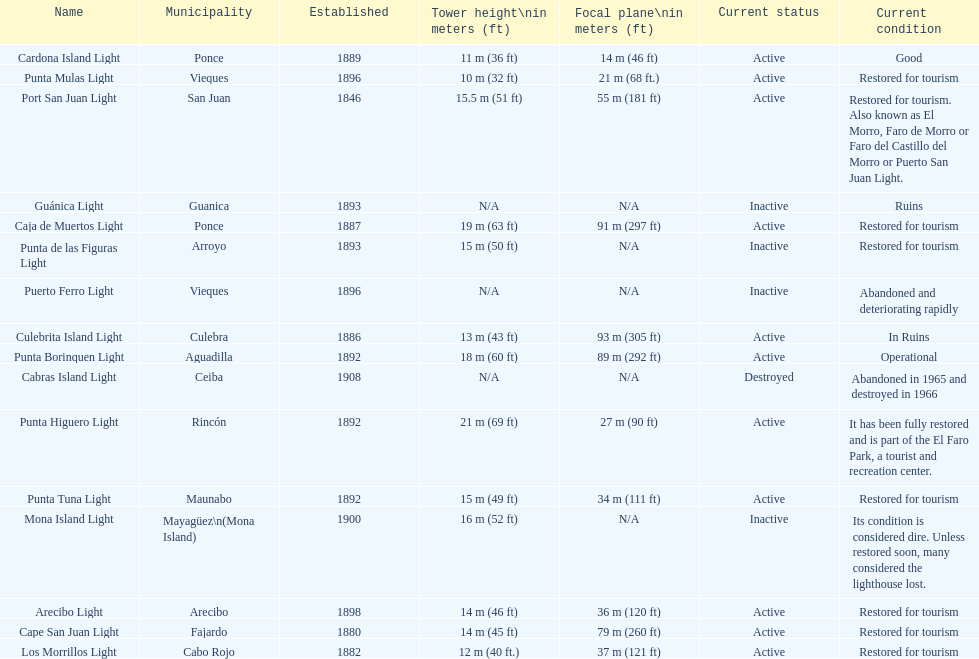Names of municipalities established before 1880 San Juan. 